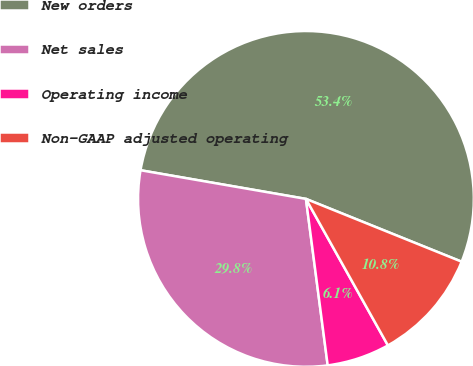<chart> <loc_0><loc_0><loc_500><loc_500><pie_chart><fcel>New orders<fcel>Net sales<fcel>Operating income<fcel>Non-GAAP adjusted operating<nl><fcel>53.37%<fcel>29.8%<fcel>6.05%<fcel>10.78%<nl></chart> 